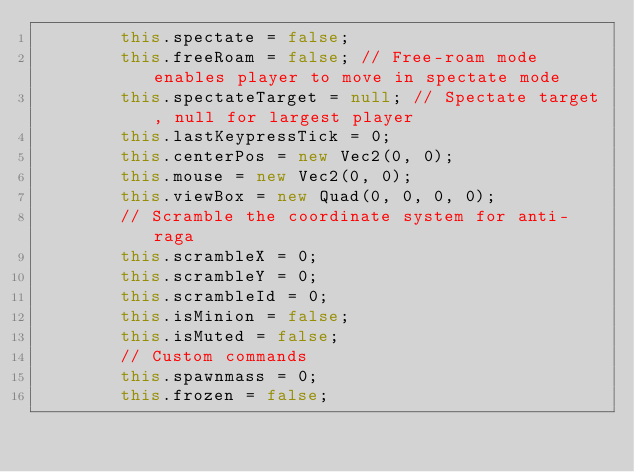<code> <loc_0><loc_0><loc_500><loc_500><_JavaScript_>        this.spectate = false;
        this.freeRoam = false; // Free-roam mode enables player to move in spectate mode
        this.spectateTarget = null; // Spectate target, null for largest player
        this.lastKeypressTick = 0;
        this.centerPos = new Vec2(0, 0);
        this.mouse = new Vec2(0, 0);
        this.viewBox = new Quad(0, 0, 0, 0);
        // Scramble the coordinate system for anti-raga
        this.scrambleX = 0;
        this.scrambleY = 0;
        this.scrambleId = 0;
        this.isMinion = false;
        this.isMuted = false;
        // Custom commands
        this.spawnmass = 0;
        this.frozen = false;</code> 